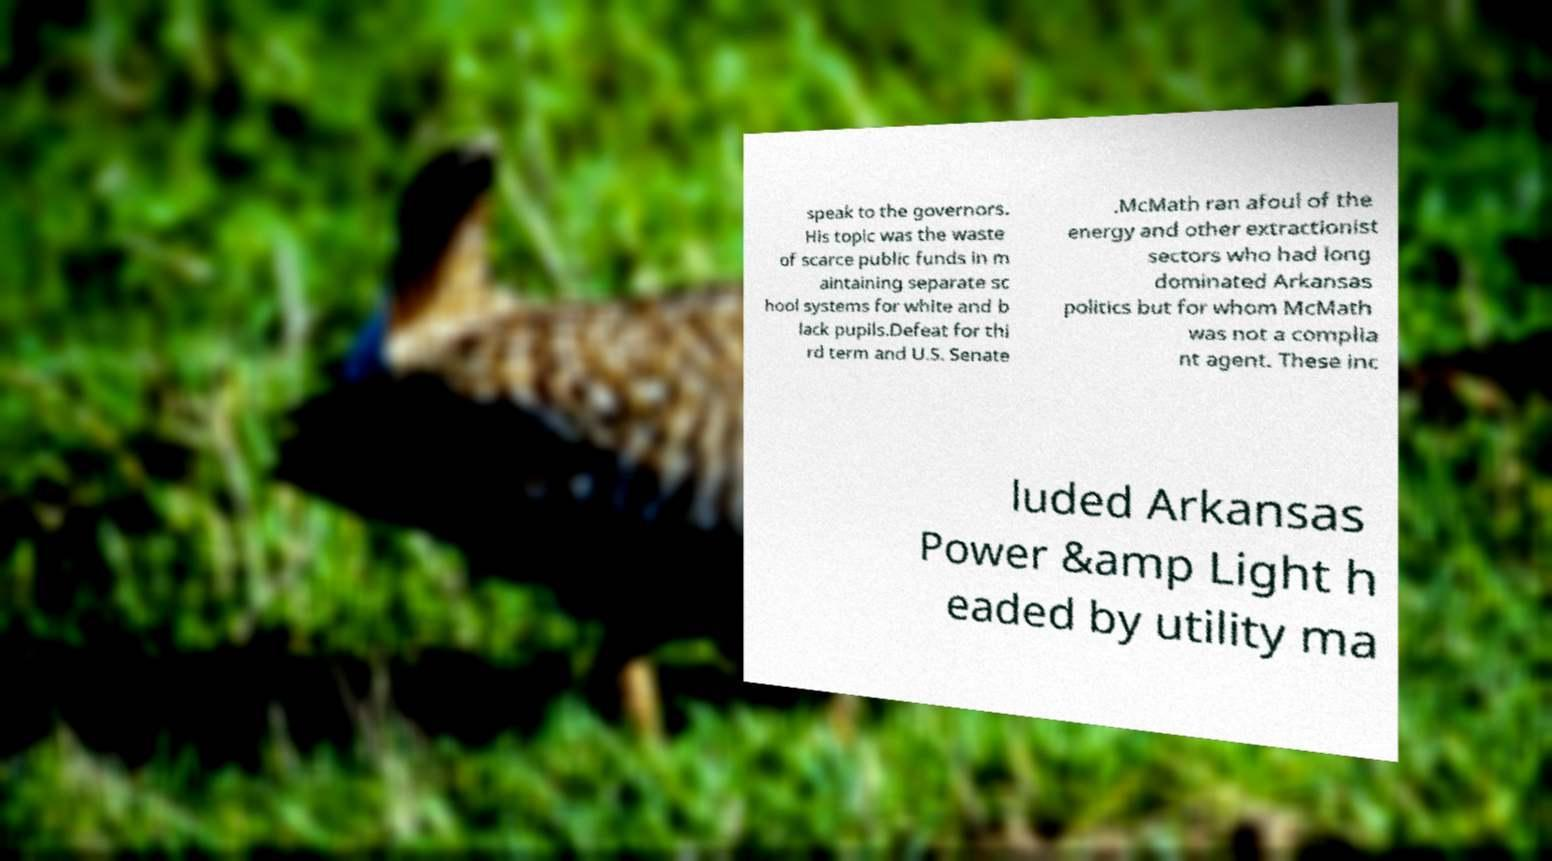Can you accurately transcribe the text from the provided image for me? speak to the governors. His topic was the waste of scarce public funds in m aintaining separate sc hool systems for white and b lack pupils.Defeat for thi rd term and U.S. Senate .McMath ran afoul of the energy and other extractionist sectors who had long dominated Arkansas politics but for whom McMath was not a complia nt agent. These inc luded Arkansas Power &amp Light h eaded by utility ma 